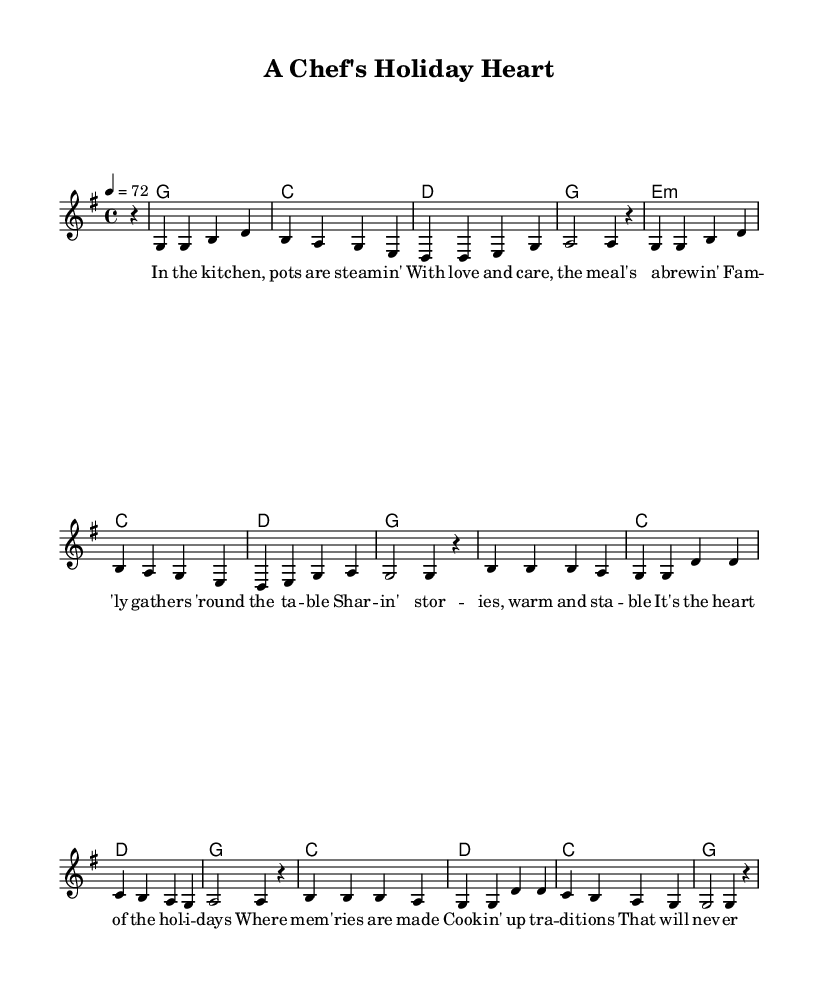What is the key signature of this music? The key signature is indicated by the placement of sharps or flats at the beginning of the staff. In this piece, there are no sharps or flats shown, which means it is in G major.
Answer: G major What is the time signature of this music? The time signature is typically displayed at the beginning of the staff and indicates how many beats are in each measure. Here, we see a 4/4 time signature, meaning there are four beats per measure.
Answer: 4/4 What is the tempo marking for this piece? The tempo marking is found above the staff, specifying the desired speed of the music. In this case, it is indicated as a quarter note equals seventy-two beats per minute.
Answer: 72 How many measures are in the melody? By counting the divisions of the music where there are bar lines, I see there are a total of twelve measures in the melody section.
Answer: 12 What instrument is primarily indicated for this music? The notation indicates a voice melody, which is typical for country ballads where lyrics and singing are emphasized. There is only one staff intended for the vocalist melody.
Answer: Voice What is the main theme of the lyrics? The lyrics discuss a holiday gathering where family shares stories and memories while enjoying food together, reflecting warmth and togetherness typical of country ballads.
Answer: Family gathering What type of harmony is used in this piece? The harmonies are indicated in chord symbols above the melody and show basic triads typical for country music. The chords here appear to be simple major and minor chords that support the melody.
Answer: Major and minor chords 